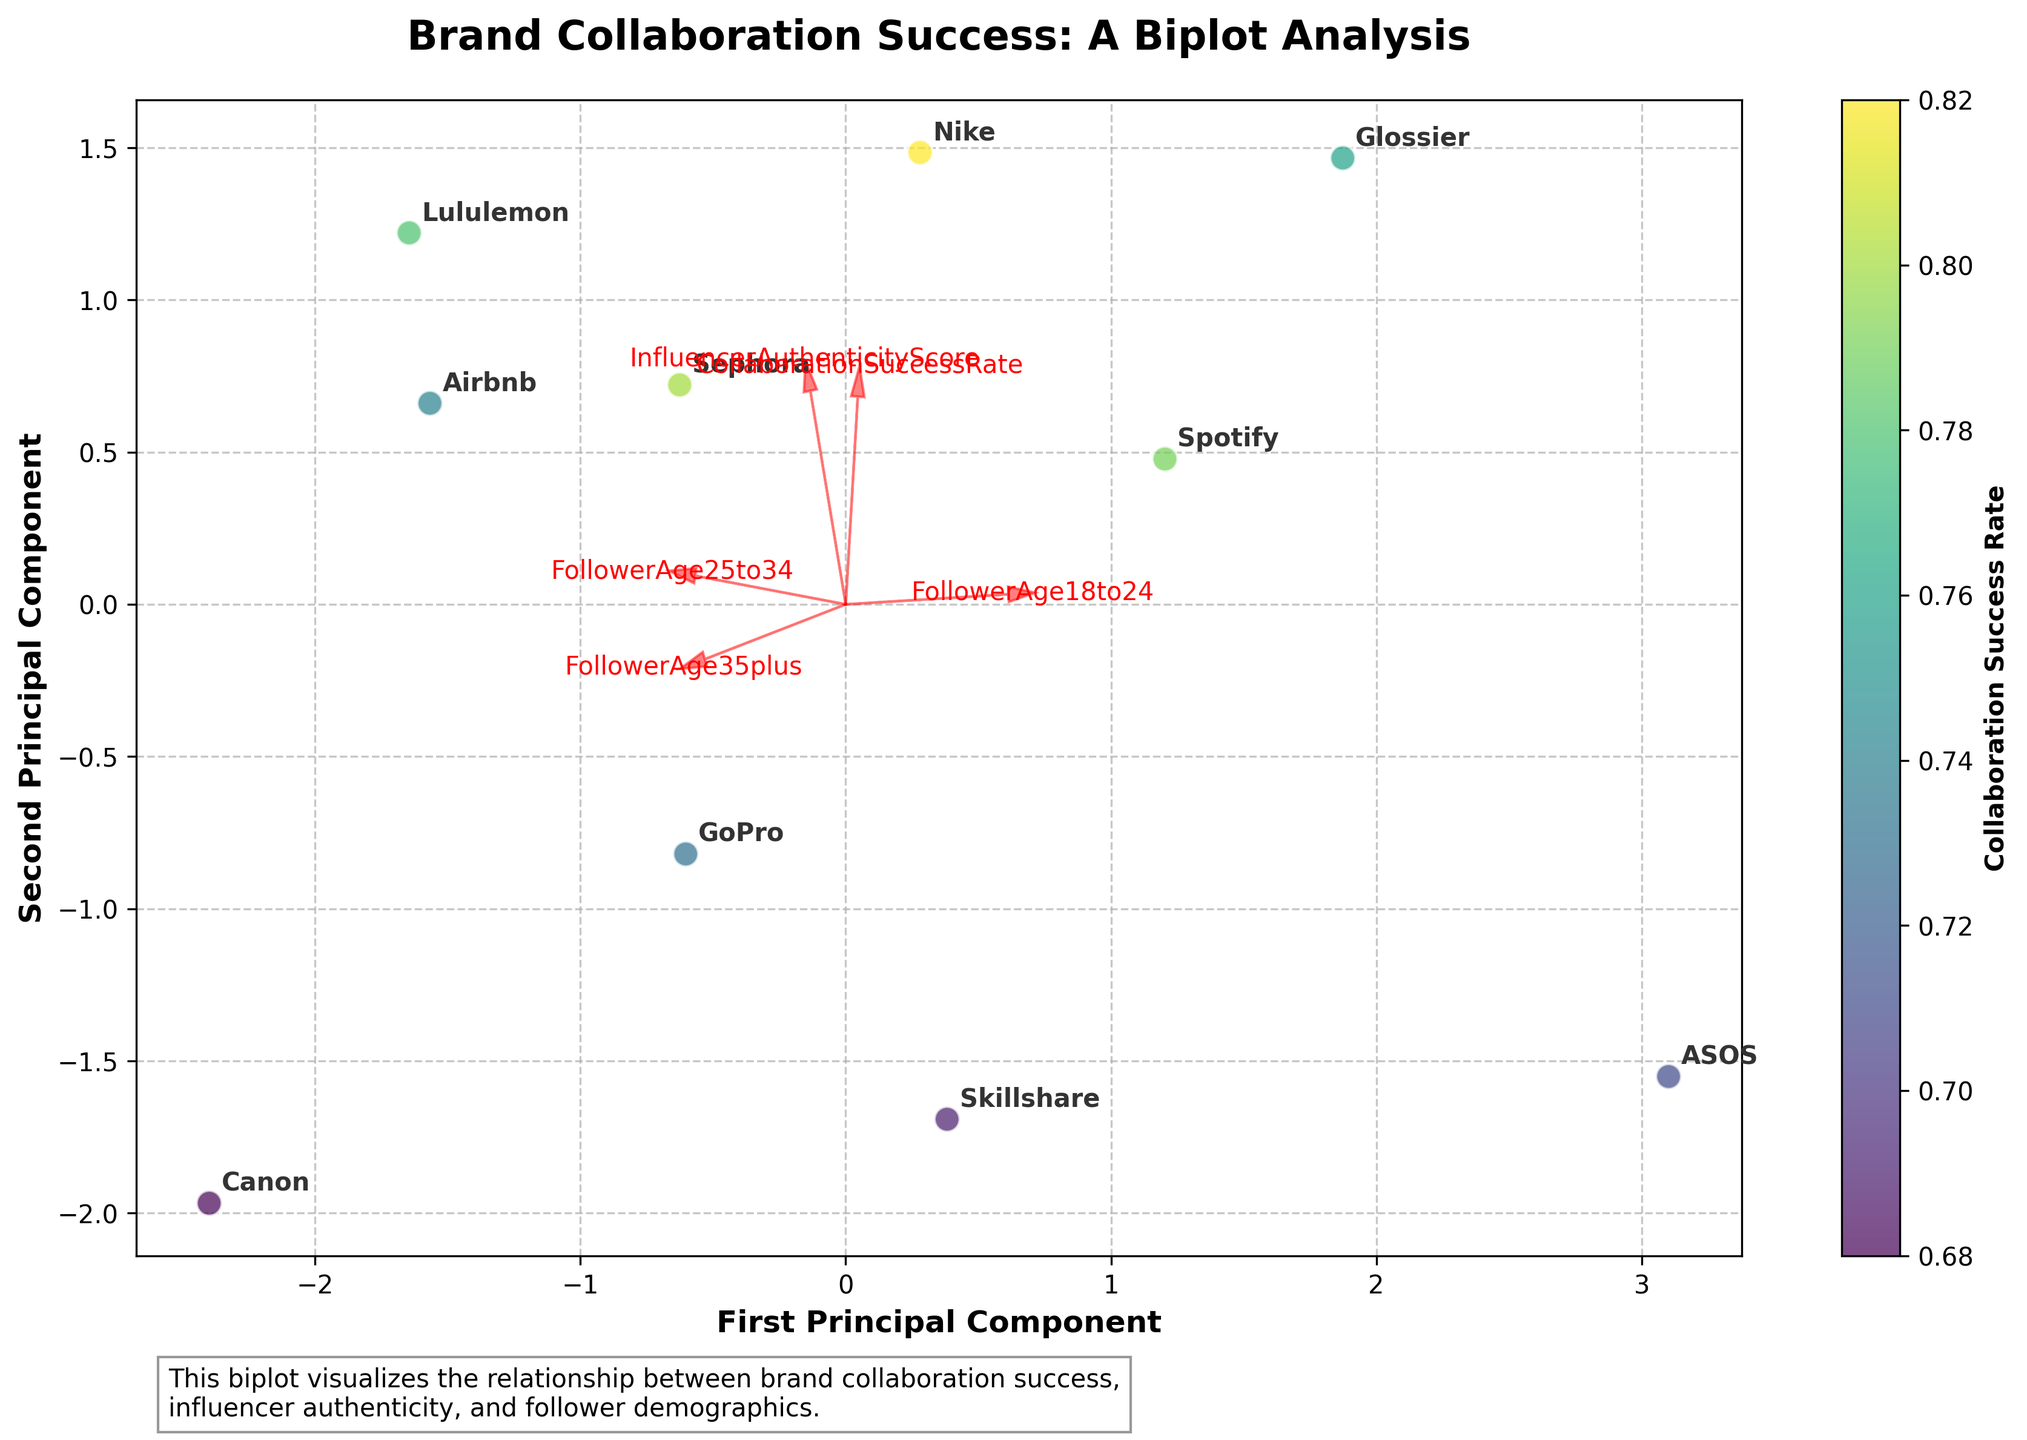How many brands are represented in the biplot? One can count the number of unique brand labels annotated in the plot. Each label corresponds to a separate brand.
Answer: 10 Which brand has the highest collaboration success rate and where is it located on the biplot? The color of each point encodes the collaboration success rate, where a lighter color indicates a higher rate. Identify the lightest color point and check its annotated label. Then locate this brand on the biplot coordinates.
Answer: Nike What are the principal components labeled on the x-axis and y-axis? The plot title and axis labels indicate the principal components. The axes are labeled "First Principal Component" and "Second Principal Component."
Answer: First Principal Component and Second Principal Component Which brand has the lowest position on the y-axis (Second Principal Component)? Identify the point with the lowest position along the y-axis (Second Principal Component), and then check the brand label annotated closest to this point.
Answer: Nike How do the features "FollowerAge18to24" and "CollaborationSuccessRate" correlate based on their vectors in the biplot? Look at the direction and length of the vectors for "FollowerAge18to24" and "CollaborationSuccessRate." If the vectors point in a similar direction, they are positively correlated; if they point in opposite directions, they are negatively correlated.
Answer: Positively correlated Based on the plot, which brands cluster closely together, and what might this indicate? Observe which points are located nearest to each other. Brands like Sephora and GoPro cluster closely, suggesting they have similar values in terms of collaboration success rate, influencer authenticity score, and follower demographics.
Answer: Sephora and GoPro Which feature has the smallest impact on the first principal component, based on the direction and length of the vectors? Examine the vectors in the plot. The vector with the smallest projection along the x-axis (First Principal Component) represents the feature with the smallest impact.
Answer: FollowerAge35plus What relationship exists between “InfluencerAuthenticityScore” and “CollaborationSuccessRate” according to their vectors? Look at the vectors for "InfluencerAuthenticityScore" and "CollaborationSuccessRate." Assess the direction and length of these vectors. If they are pointing in similar directions, there is a positive relationship.
Answer: Positive relationship Which brand has the closest position to the origin (0,0) of the biplot, and what might this imply? Identify the data point nearest to the origin. The brand labeled closest to this point will be the one you are looking for. This may imply it has average values for the features compared to other brands.
Answer: Skillshare Among the brands, which one has the most followers aged 18 to 24, and how is this reflected in the biplot? The brand with the highest value in the "FollowerAge18to24" vector should be farthest along the direction of this vector. Check which brand is positioned this way.
Answer: ASOS 